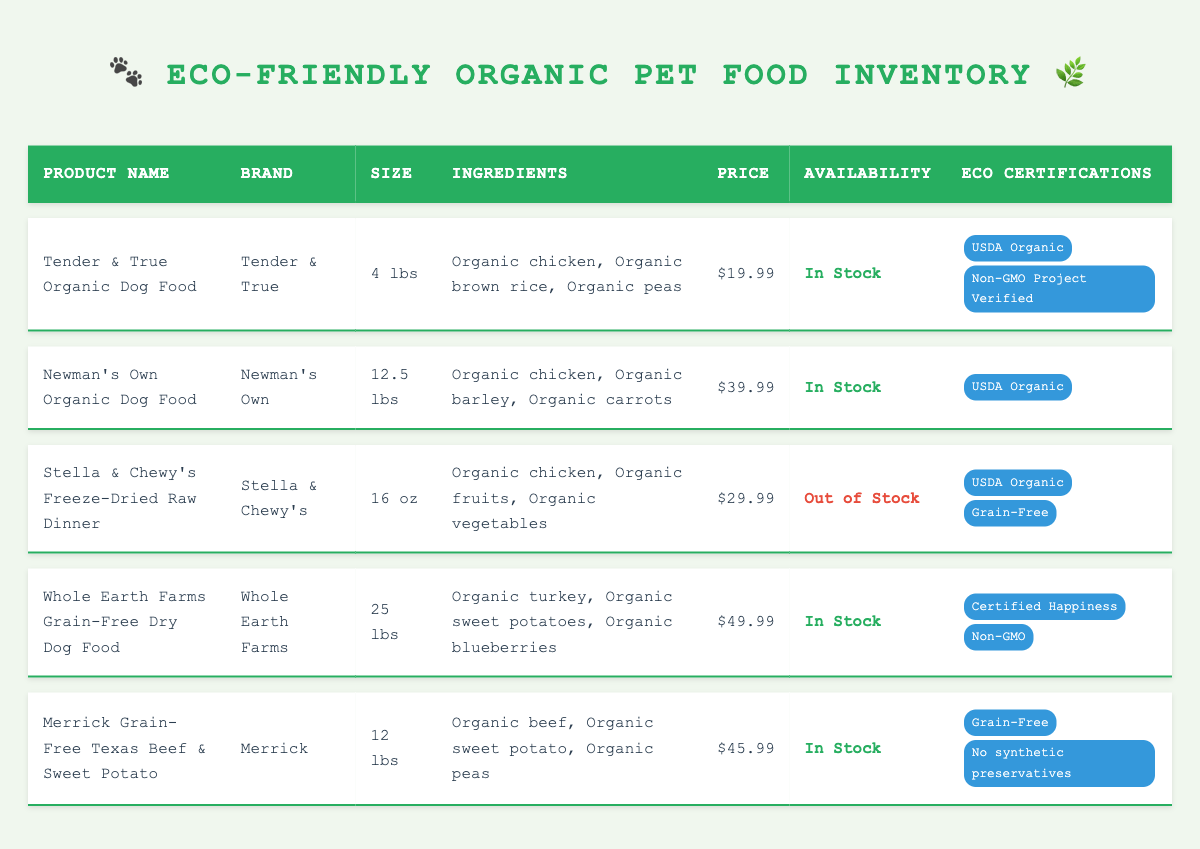What is the price of Tender & True Organic Dog Food? The price of Tender & True Organic Dog Food is listed directly in the table under the Price column as 19.99.
Answer: 19.99 Is Whole Earth Farms Grain-Free Dry Dog Food available? The availability of Whole Earth Farms Grain-Free Dry Dog Food is indicated in the Availability column, where it states "In Stock."
Answer: Yes Which product has the highest price? To determine the highest price, we compare the prices of all products: 19.99 (Tender & True), 39.99 (Newman's Own), 29.99 (Stella & Chewy's), 49.99 (Whole Earth Farms), and 45.99 (Merrick). The highest price is 49.99 for Whole Earth Farms Grain-Free Dry Dog Food.
Answer: Whole Earth Farms Grain-Free Dry Dog Food How many products are certified as USDA Organic? The table shows that three products are listed with "USDA Organic" in the Eco Certifications column. They are Tender & True Organic Dog Food, Newman's Own Organic Dog Food, and Stella & Chewy's Freeze-Dried Raw Dinner.
Answer: 3 What is the average price of the in-stock products? The prices of the in-stock products are 19.99 (Tender & True), 39.99 (Newman's Own), 49.99 (Whole Earth Farms), and 45.99 (Merrick), making a total of 19.99 + 39.99 + 49.99 + 45.99 = 155.96. Dividing this by the number of in-stock products, which is 4, gives an average of 155.96/4 = 38.99.
Answer: 38.99 Are there any products that contain peas as an ingredient? By examining the Ingredients column, we can identify which products contain peas: Tender & True Organic Dog Food, Stella & Chewy's Freeze-Dried Raw Dinner, and Merrick Grain-Free Texas Beef & Sweet Potato all list organic peas. Hence, there are products that contain peas.
Answer: Yes Is there any product that is both out of stock and grain-free? Looking at the Availability column, Stella & Chewy's Freeze-Dried Raw Dinner is marked as "Out of Stock" and in the Eco Certifications column, it is also noted as "Grain-Free." Thus, this product is both out of stock and grain-free.
Answer: Yes How many types of eco certifications does the Merrick product have? The Merrick Grain-Free Texas Beef & Sweet Potato product has two eco certifications listed in the table. These are "Grain-Free" and "No synthetic preservatives."
Answer: 2 What ingredients are in the Newman's Own Organic Dog Food? The Ingredients column for Newman's Own Organic Dog Food lists "Organic chicken, Organic barley, Organic carrots." This information can be directly retrieved from the table.
Answer: Organic chicken, Organic barley, Organic carrots 